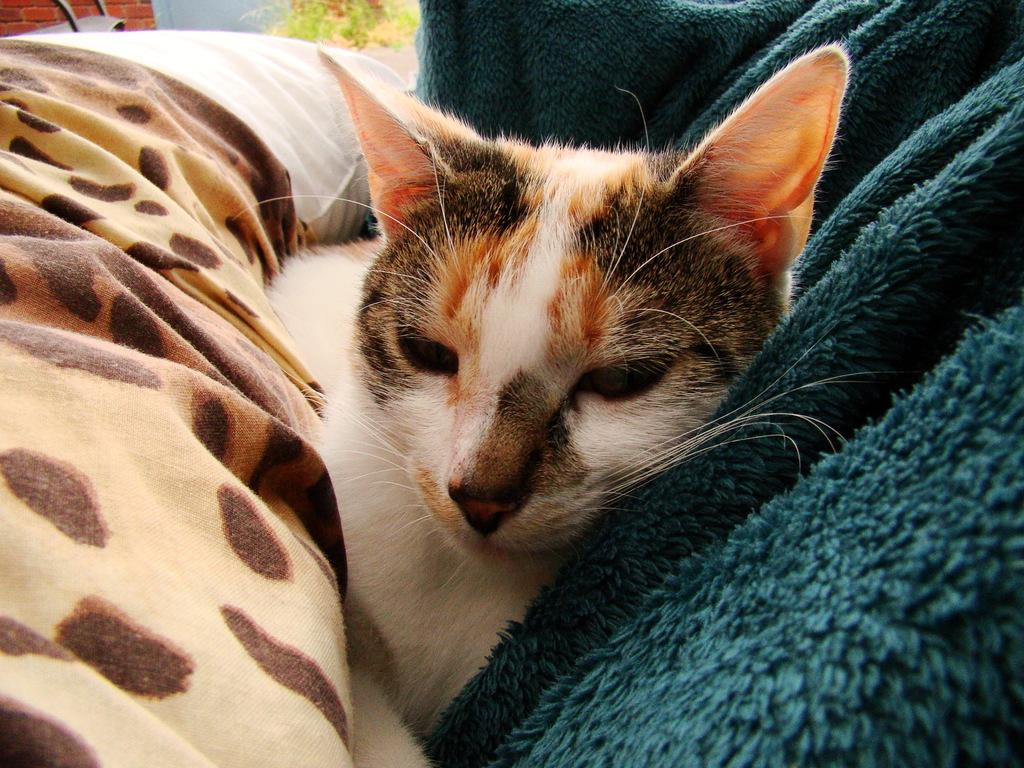What type of animal is present in the image? There is a cat in the image. Where is the cat located in the image? The cat is under a blanket. What can be seen in the top left corner of the image? There is a pillow, plants, and a wall in the top left corner of the image. What is on the right side of the image? There is another blanket on the right side of the image. What type of books can be seen in the image? There are no books or library depicted in the image. How does the cat sort the blankets in the image? The cat does not sort blankets in the image; it is simply under one of them. 